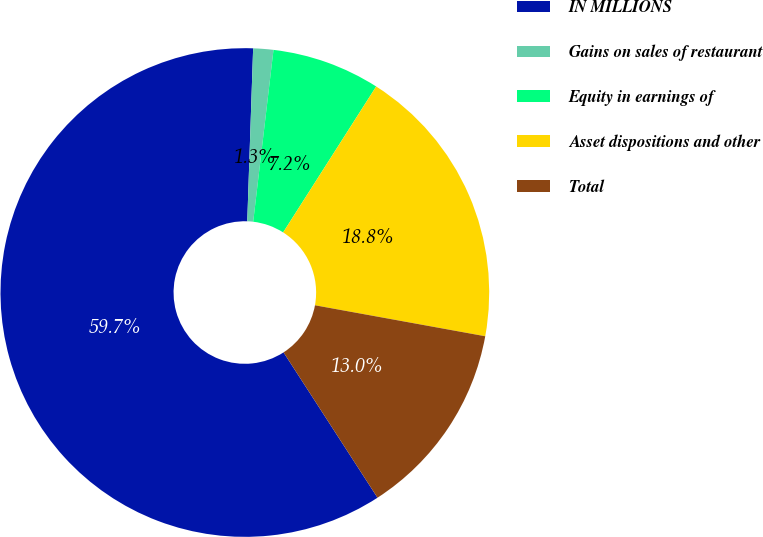Convert chart. <chart><loc_0><loc_0><loc_500><loc_500><pie_chart><fcel>IN MILLIONS<fcel>Gains on sales of restaurant<fcel>Equity in earnings of<fcel>Asset dispositions and other<fcel>Total<nl><fcel>59.67%<fcel>1.33%<fcel>7.16%<fcel>18.83%<fcel>13.0%<nl></chart> 